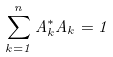Convert formula to latex. <formula><loc_0><loc_0><loc_500><loc_500>\sum _ { k = 1 } ^ { n } A _ { k } ^ { * } A _ { k } = 1</formula> 